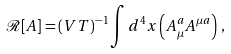<formula> <loc_0><loc_0><loc_500><loc_500>\mathcal { R } [ A ] = ( V T ) ^ { - 1 } \int d ^ { 4 } x \left ( A _ { \mu } ^ { a } A ^ { \mu a } \right ) \, ,</formula> 